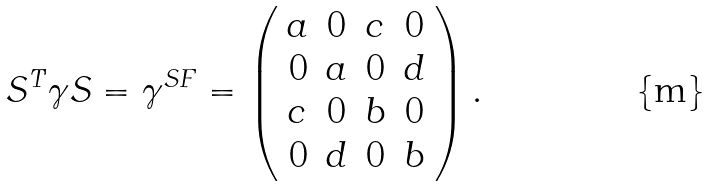<formula> <loc_0><loc_0><loc_500><loc_500>S ^ { T } \gamma S = \gamma ^ { S F } = \left ( \begin{array} { c c c c } a & 0 & c & 0 \\ 0 & a & 0 & d \\ c & 0 & b & 0 \\ 0 & d & 0 & b \end{array} \right ) .</formula> 